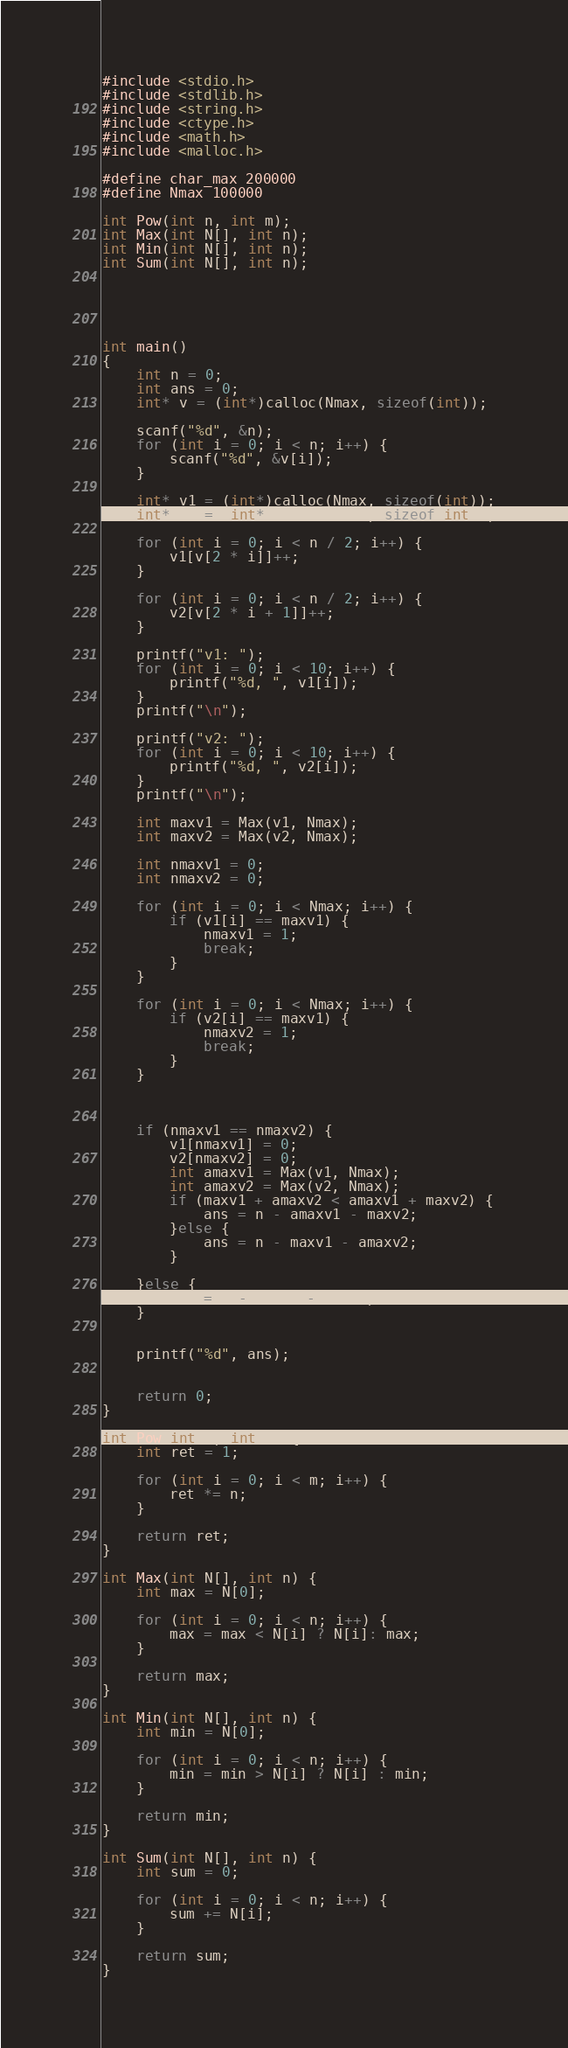Convert code to text. <code><loc_0><loc_0><loc_500><loc_500><_C_>#include <stdio.h>
#include <stdlib.h>
#include <string.h>
#include <ctype.h>
#include <math.h>
#include <malloc.h>

#define char_max 200000
#define Nmax 100000

int Pow(int n, int m);
int Max(int N[], int n);
int Min(int N[], int n);
int Sum(int N[], int n);





int main()
{
	int n = 0;
	int ans = 0;
	int* v = (int*)calloc(Nmax, sizeof(int));

	scanf("%d", &n);
	for (int i = 0; i < n; i++) {
		scanf("%d", &v[i]);
	}

	int* v1 = (int*)calloc(Nmax, sizeof(int));
	int* v2 = (int*)calloc(Nmax, sizeof(int));

	for (int i = 0; i < n / 2; i++) {
		v1[v[2 * i]]++;
	}

	for (int i = 0; i < n / 2; i++) {
		v2[v[2 * i + 1]]++;
	}
	
	printf("v1: ");
	for (int i = 0; i < 10; i++) {
		printf("%d, ", v1[i]);
	}
	printf("\n");

	printf("v2: ");
	for (int i = 0; i < 10; i++) {
		printf("%d, ", v2[i]);
	}
	printf("\n");

	int maxv1 = Max(v1, Nmax);
	int maxv2 = Max(v2, Nmax);

	int nmaxv1 = 0;
	int nmaxv2 = 0;

	for (int i = 0; i < Nmax; i++) {
		if (v1[i] == maxv1) {
			nmaxv1 = 1;
			break;
		}
	}

	for (int i = 0; i < Nmax; i++) {
		if (v2[i] == maxv1) {
			nmaxv2 = 1;
			break;
		}
	}

	
	
	if (nmaxv1 == nmaxv2) {
		v1[nmaxv1] = 0;
		v2[nmaxv2] = 0;
		int amaxv1 = Max(v1, Nmax);
		int amaxv2 = Max(v2, Nmax);
		if (maxv1 + amaxv2 < amaxv1 + maxv2) {
			ans = n - amaxv1 - maxv2;
		}else {
			ans = n - maxv1 - amaxv2;
		}

	}else {
		ans = n - maxv1 - maxv2;
	}
	

	printf("%d", ans);


	return 0;
}

int Pow(int n, int m) {
	int ret = 1;

	for (int i = 0; i < m; i++) {
		ret *= n;
	}

	return ret;
}

int Max(int N[], int n) {
	int max = N[0];

	for (int i = 0; i < n; i++) {
		max = max < N[i] ? N[i]: max;
	}

	return max;
}

int Min(int N[], int n) {
	int min = N[0];

	for (int i = 0; i < n; i++) {
		min = min > N[i] ? N[i] : min;
	}

	return min;
}

int Sum(int N[], int n) {
	int sum = 0;

	for (int i = 0; i < n; i++) {
		sum += N[i];
	}

	return sum;
}</code> 